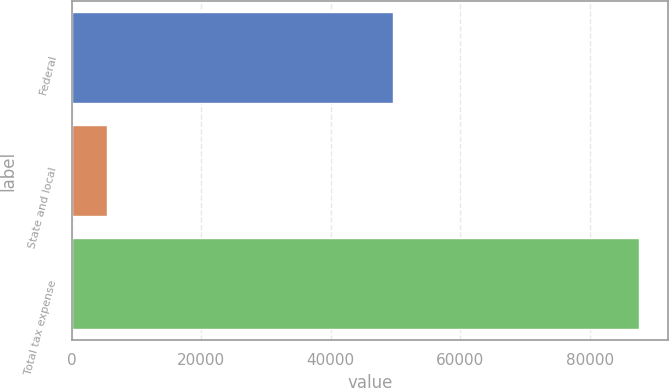<chart> <loc_0><loc_0><loc_500><loc_500><bar_chart><fcel>Federal<fcel>State and local<fcel>Total tax expense<nl><fcel>49597<fcel>5416<fcel>87633<nl></chart> 